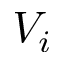Convert formula to latex. <formula><loc_0><loc_0><loc_500><loc_500>V _ { i }</formula> 